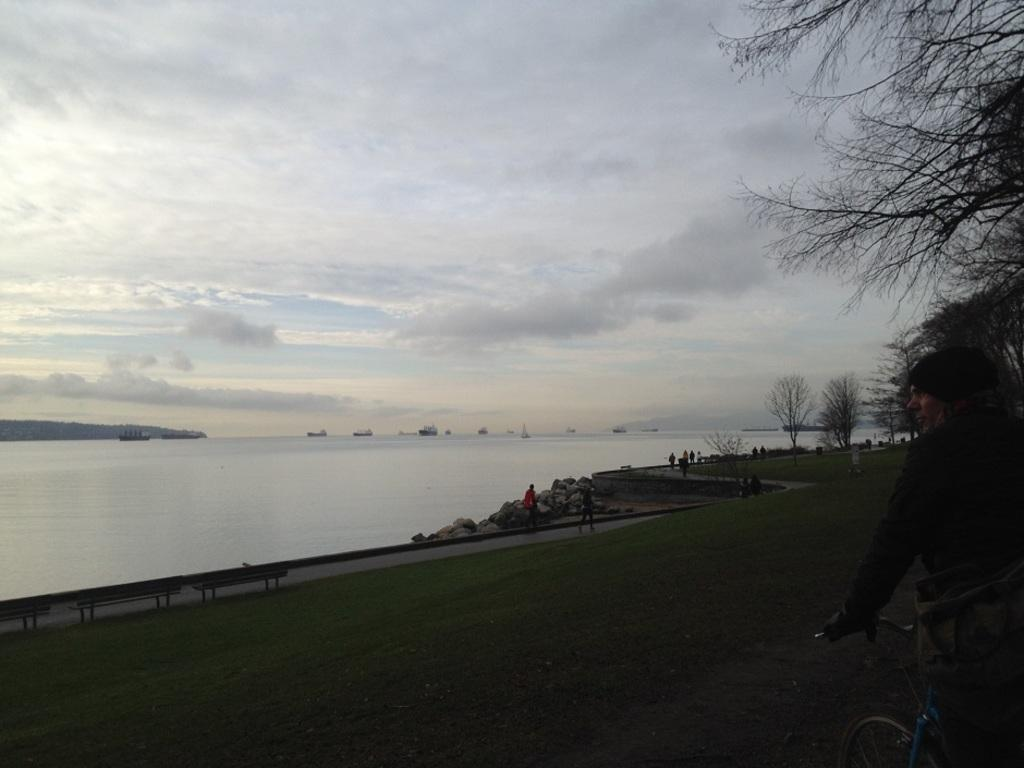What can be seen in the sky in the image? The sky is visible in the image with clouds. What is the main feature of the landscape in the image? There is water in the image. What is located near the water? There is a footpath near the water. What is available for people to sit on the footpath? Benches are present on the footpath. What are people doing on the footpath? People are walking on the footpath. What type of vegetation is visible in the image? Trees are visible in the image. What mode of transportation can be seen in the image? There is a bicycle in the image. What else is present on the water in the image? Ships are present on the water. Where is the shelf located in the image? There is no shelf present in the image. What type of hat is being worn by the trees in the image? Trees do not wear hats; they are plants and do not have the ability to wear clothing or accessories. 